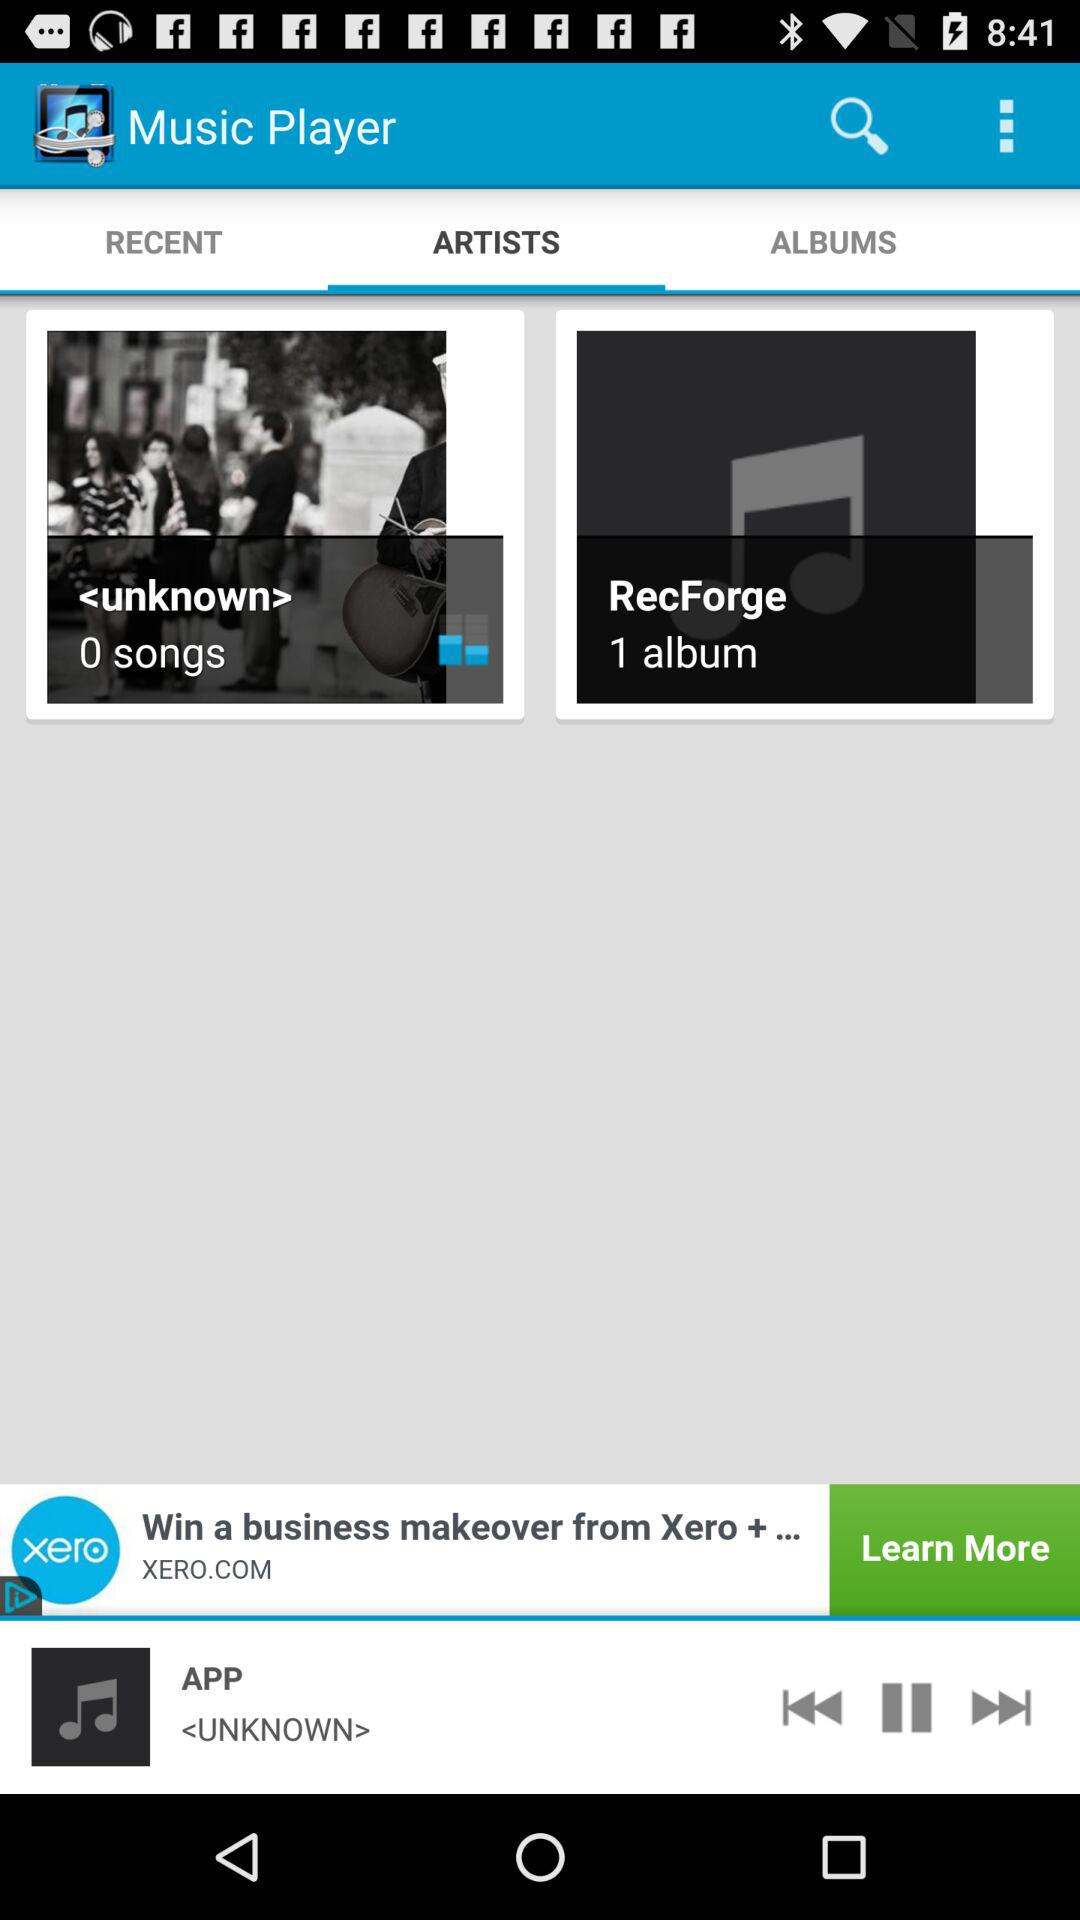What is the number of albums in "RecForge"? The number of albums is 1. 